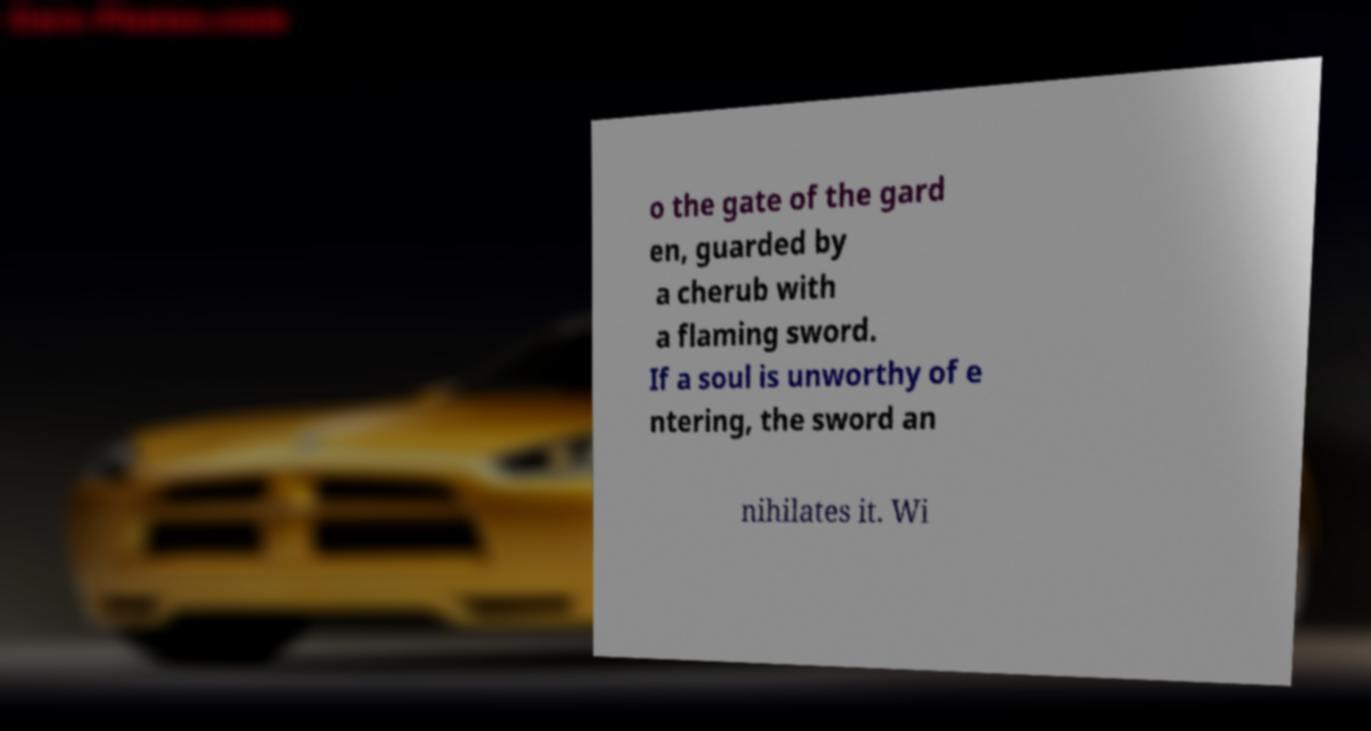Please read and relay the text visible in this image. What does it say? o the gate of the gard en, guarded by a cherub with a flaming sword. If a soul is unworthy of e ntering, the sword an nihilates it. Wi 